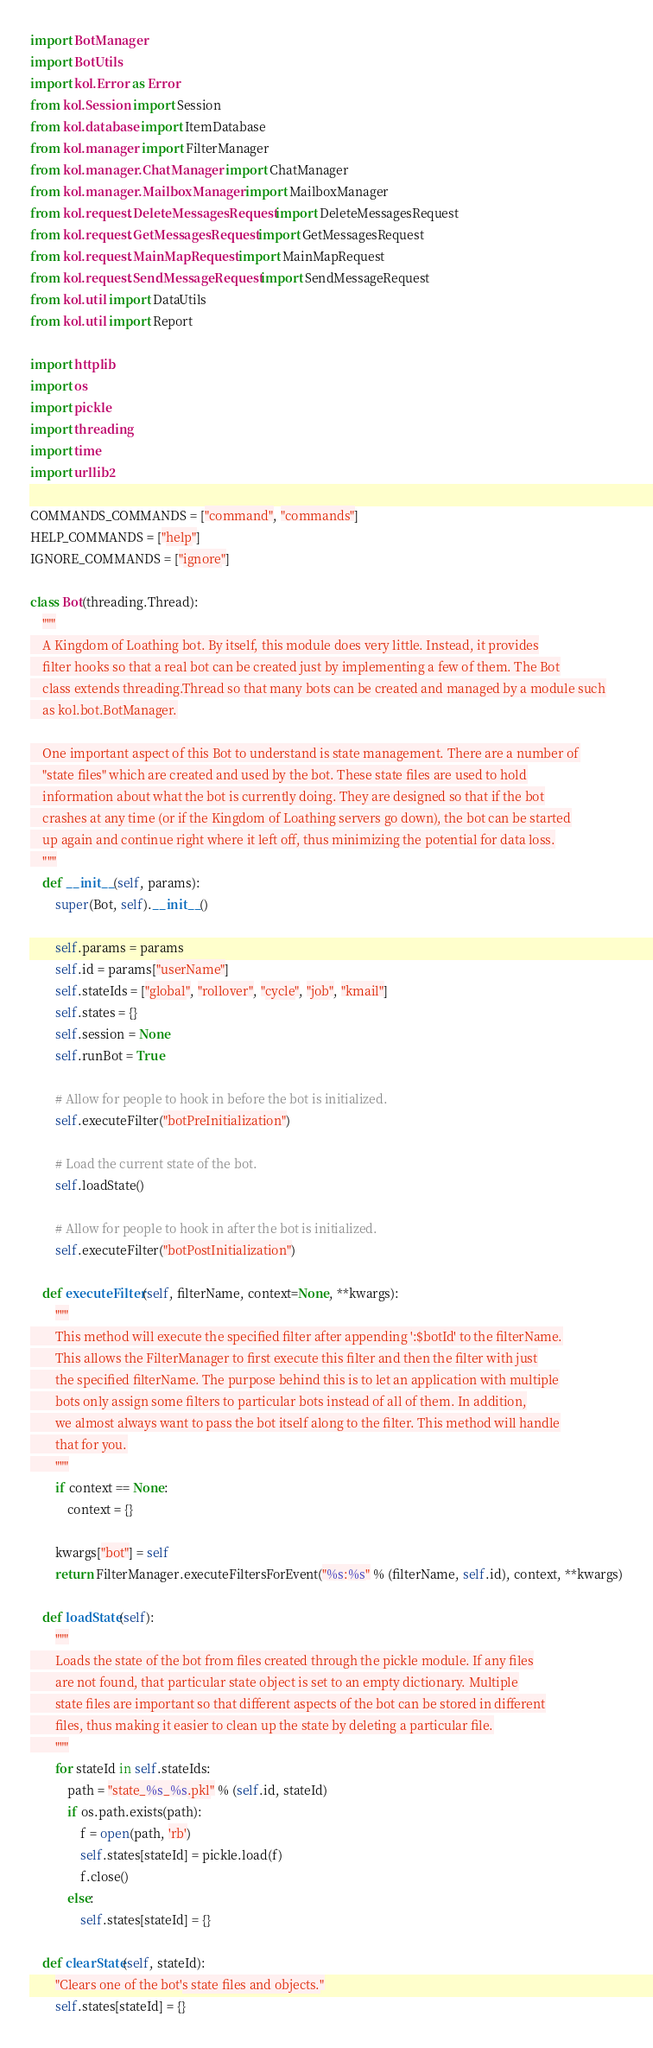Convert code to text. <code><loc_0><loc_0><loc_500><loc_500><_Python_>import BotManager
import BotUtils
import kol.Error as Error
from kol.Session import Session
from kol.database import ItemDatabase
from kol.manager import FilterManager
from kol.manager.ChatManager import ChatManager
from kol.manager.MailboxManager import MailboxManager
from kol.request.DeleteMessagesRequest import DeleteMessagesRequest
from kol.request.GetMessagesRequest import GetMessagesRequest
from kol.request.MainMapRequest import MainMapRequest
from kol.request.SendMessageRequest import SendMessageRequest
from kol.util import DataUtils
from kol.util import Report

import httplib
import os
import pickle
import threading
import time
import urllib2

COMMANDS_COMMANDS = ["command", "commands"]
HELP_COMMANDS = ["help"]
IGNORE_COMMANDS = ["ignore"]

class Bot(threading.Thread):
    """
    A Kingdom of Loathing bot. By itself, this module does very little. Instead, it provides
    filter hooks so that a real bot can be created just by implementing a few of them. The Bot
    class extends threading.Thread so that many bots can be created and managed by a module such
    as kol.bot.BotManager.

    One important aspect of this Bot to understand is state management. There are a number of
    "state files" which are created and used by the bot. These state files are used to hold
    information about what the bot is currently doing. They are designed so that if the bot
    crashes at any time (or if the Kingdom of Loathing servers go down), the bot can be started
    up again and continue right where it left off, thus minimizing the potential for data loss.
    """
    def __init__(self, params):
        super(Bot, self).__init__()

        self.params = params
        self.id = params["userName"]
        self.stateIds = ["global", "rollover", "cycle", "job", "kmail"]
        self.states = {}
        self.session = None
        self.runBot = True

        # Allow for people to hook in before the bot is initialized.
        self.executeFilter("botPreInitialization")

        # Load the current state of the bot.
        self.loadState()

        # Allow for people to hook in after the bot is initialized.
        self.executeFilter("botPostInitialization")

    def executeFilter(self, filterName, context=None, **kwargs):
        """
        This method will execute the specified filter after appending ':$botId' to the filterName.
        This allows the FilterManager to first execute this filter and then the filter with just
        the specified filterName. The purpose behind this is to let an application with multiple
        bots only assign some filters to particular bots instead of all of them. In addition,
        we almost always want to pass the bot itself along to the filter. This method will handle
        that for you.
        """
        if context == None:
            context = {}

        kwargs["bot"] = self
        return FilterManager.executeFiltersForEvent("%s:%s" % (filterName, self.id), context, **kwargs)

    def loadState(self):
        """
        Loads the state of the bot from files created through the pickle module. If any files
        are not found, that particular state object is set to an empty dictionary. Multiple
        state files are important so that different aspects of the bot can be stored in different
        files, thus making it easier to clean up the state by deleting a particular file.
        """
        for stateId in self.stateIds:
            path = "state_%s_%s.pkl" % (self.id, stateId)
            if os.path.exists(path):
                f = open(path, 'rb')
                self.states[stateId] = pickle.load(f)
                f.close()
            else:
                self.states[stateId] = {}

    def clearState(self, stateId):
        "Clears one of the bot's state files and objects."
        self.states[stateId] = {}</code> 